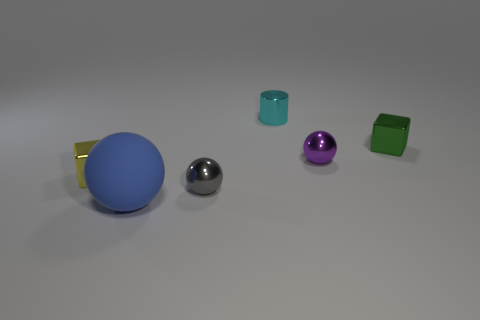Subtract all blue balls. How many balls are left? 2 Add 3 small purple cubes. How many objects exist? 9 Subtract all cylinders. How many objects are left? 5 Subtract all blue spheres. How many spheres are left? 2 Subtract 3 spheres. How many spheres are left? 0 Add 3 metal objects. How many metal objects are left? 8 Add 2 small spheres. How many small spheres exist? 4 Subtract 0 purple blocks. How many objects are left? 6 Subtract all blue balls. Subtract all yellow cubes. How many balls are left? 2 Subtract all gray spheres. How many green cubes are left? 1 